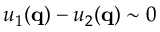<formula> <loc_0><loc_0><loc_500><loc_500>u _ { 1 } ( q ) - u _ { 2 } ( q ) \sim 0</formula> 